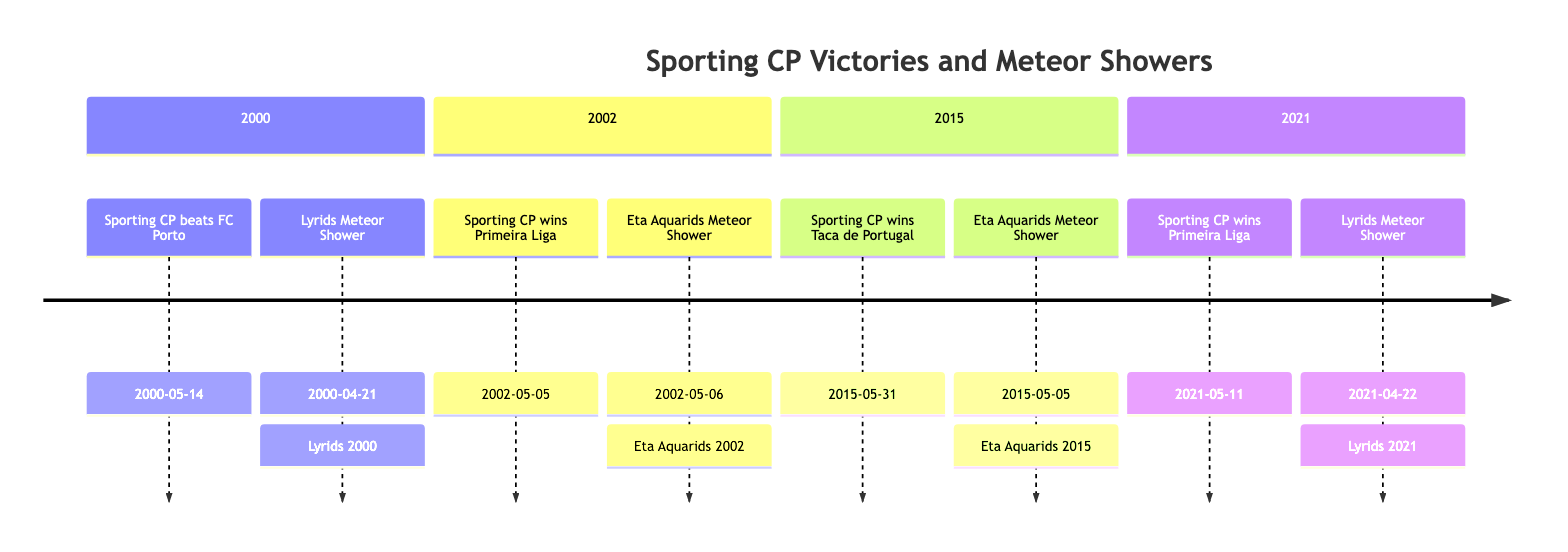What is the date of Sporting CP's victory against FC Porto? The diagram indicates that the match occurred on May 14, 2000, which is labeled next to the event "Sporting CP beats FC Porto."
Answer: May 14, 2000 How many significant events are marked in the year 2015? By examining the timeline for the year 2015, I find two events listed: "Sporting CP wins Taca de Portugal" and "Eta Aquarids Meteor Shower." Therefore, the total count is two events.
Answer: 2 What is the meteor shower associated with Sporting CP's 2021 Primeira Liga win? The event labeled "Sporting CP wins Primeira Liga" in 2021 is associated with the "Lyrids Meteor Shower," which is noted right next to the victory date on the timeline.
Answer: Lyrids Meteor Shower What date does the Eta Aquarids Meteor Shower occur in 2002? The diagram specifies that the Eta Aquarids Meteor Shower event in 2002 is marked on the date of May 6, 2002, which is clearly indicated next to the meteor shower entry.
Answer: May 6, 2002 Which meteor shower coincided with two different sporting events? Looking through the timeline, the "Eta Aquarids Meteor Shower" appears in both 2002 and 2015, indicating it coincided with Sporting CP victories during those years.
Answer: Eta Aquarids Meteor Shower What major achievement did Sporting CP accomplish on May 5, 2002? The timeline states that Sporting CP won the Primeira Liga on May 5, 2002, which is clearly noted in the respective section of the diagram.
Answer: Primeira Liga 